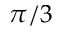Convert formula to latex. <formula><loc_0><loc_0><loc_500><loc_500>\pi / 3</formula> 